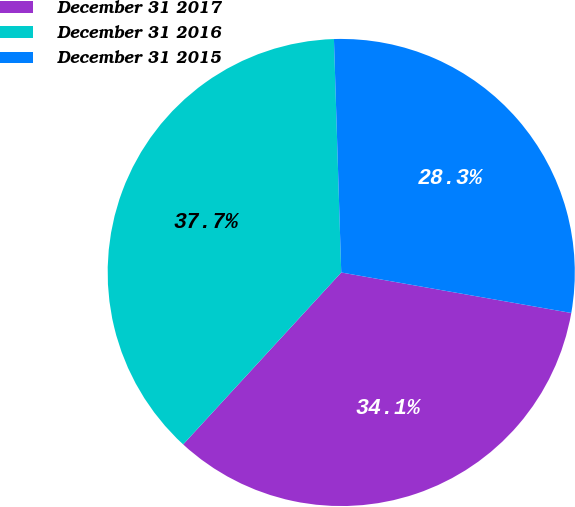Convert chart. <chart><loc_0><loc_0><loc_500><loc_500><pie_chart><fcel>December 31 2017<fcel>December 31 2016<fcel>December 31 2015<nl><fcel>34.06%<fcel>37.67%<fcel>28.27%<nl></chart> 